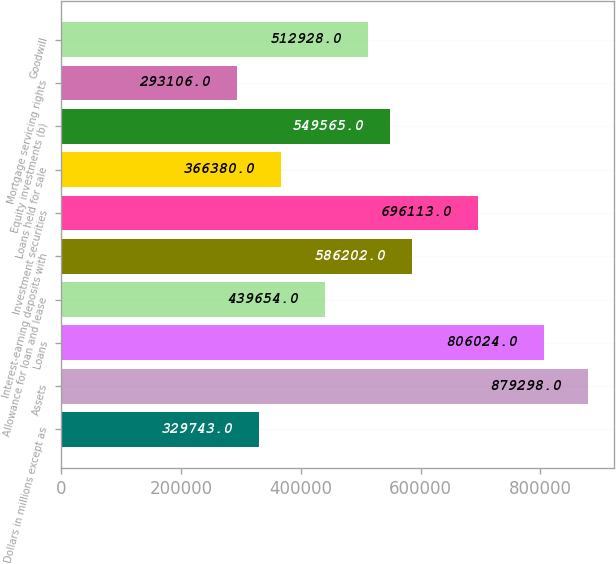Convert chart. <chart><loc_0><loc_0><loc_500><loc_500><bar_chart><fcel>Dollars in millions except as<fcel>Assets<fcel>Loans<fcel>Allowance for loan and lease<fcel>Interest-earning deposits with<fcel>Investment securities<fcel>Loans held for sale<fcel>Equity investments (b)<fcel>Mortgage servicing rights<fcel>Goodwill<nl><fcel>329743<fcel>879298<fcel>806024<fcel>439654<fcel>586202<fcel>696113<fcel>366380<fcel>549565<fcel>293106<fcel>512928<nl></chart> 